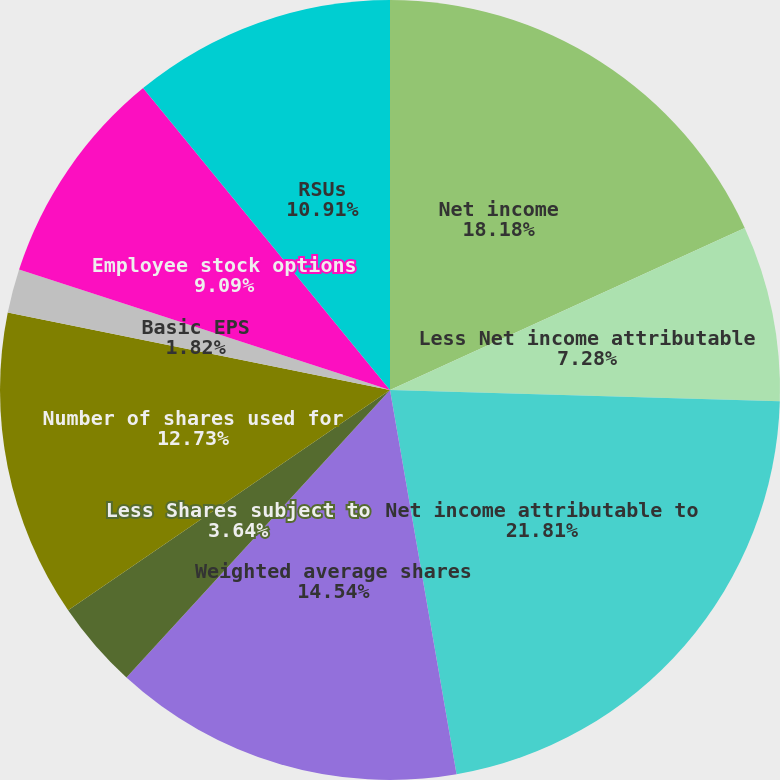Convert chart to OTSL. <chart><loc_0><loc_0><loc_500><loc_500><pie_chart><fcel>Net income<fcel>Less Net income attributable<fcel>Net income attributable to<fcel>Weighted average shares<fcel>Less Shares subject to<fcel>Number of shares used for<fcel>Basic EPS<fcel>Employee stock options<fcel>RSUs<nl><fcel>18.18%<fcel>7.28%<fcel>21.81%<fcel>14.54%<fcel>3.64%<fcel>12.73%<fcel>1.82%<fcel>9.09%<fcel>10.91%<nl></chart> 